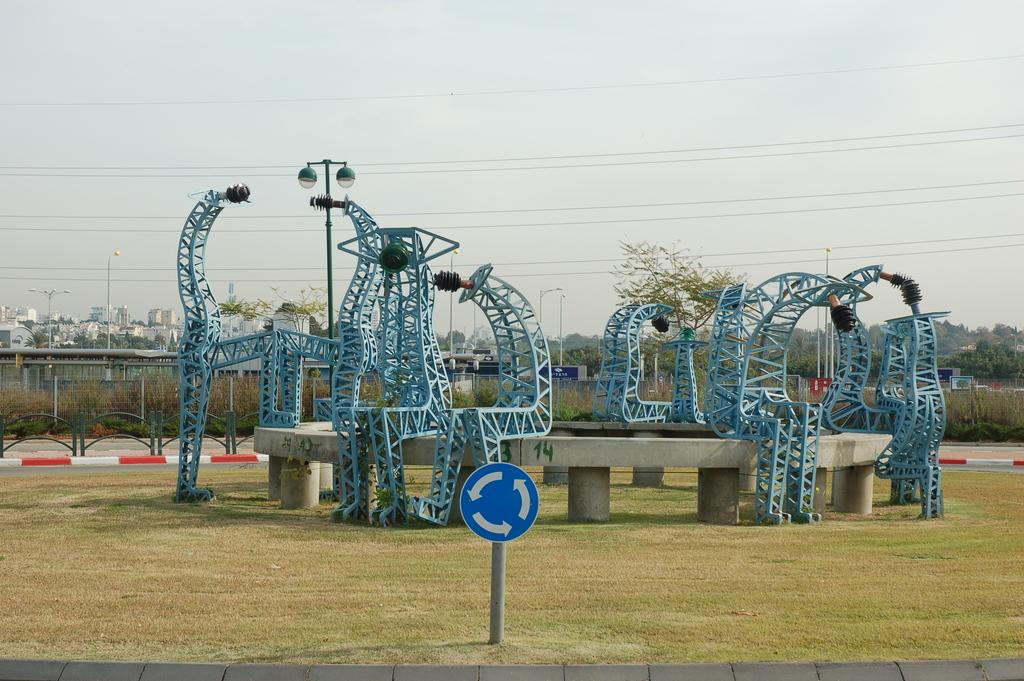What type of vegetation can be seen in the image? Grass, plants, and trees are visible in the image. What object is present in the image that is typically used for displaying information or messages? There is a board in the image. What type of material is used for the objects that are present in the image? Metal objects are present in the image. What structures can be seen supporting the lights in the image? Poles are visible in the image. What is the purpose of the lights in the image? The lights are present in the image, but their purpose is not explicitly stated. What type of barrier can be seen in the image? There is a fence in the image. What type of structures can be seen in the background of the image? There are buildings in the background of the image. What part of the natural environment is visible in the background of the image? The sky is visible in the background of the image. Can you see any ants carrying leaves in the image? There are no ants or leaves present in the image. What sense is being used by the stone in the image? There is no stone present in the image, and therefore no sense is being used. 